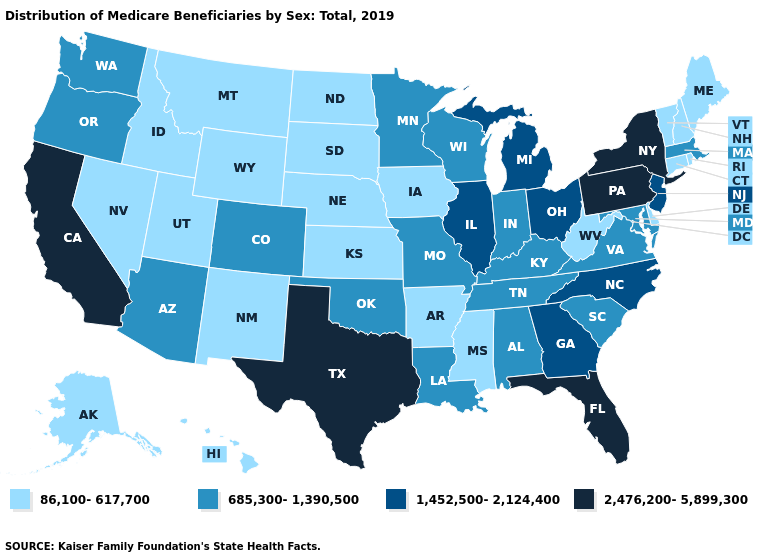Which states hav the highest value in the Northeast?
Keep it brief. New York, Pennsylvania. What is the value of Michigan?
Concise answer only. 1,452,500-2,124,400. What is the highest value in the USA?
Be succinct. 2,476,200-5,899,300. Does Hawaii have the lowest value in the USA?
Concise answer only. Yes. Among the states that border Louisiana , does Arkansas have the highest value?
Keep it brief. No. Name the states that have a value in the range 1,452,500-2,124,400?
Answer briefly. Georgia, Illinois, Michigan, New Jersey, North Carolina, Ohio. Does New York have the highest value in the USA?
Short answer required. Yes. Name the states that have a value in the range 2,476,200-5,899,300?
Quick response, please. California, Florida, New York, Pennsylvania, Texas. Does the map have missing data?
Write a very short answer. No. What is the value of Rhode Island?
Give a very brief answer. 86,100-617,700. Which states have the lowest value in the MidWest?
Short answer required. Iowa, Kansas, Nebraska, North Dakota, South Dakota. Does Tennessee have a higher value than Massachusetts?
Short answer required. No. Name the states that have a value in the range 2,476,200-5,899,300?
Be succinct. California, Florida, New York, Pennsylvania, Texas. What is the highest value in the West ?
Answer briefly. 2,476,200-5,899,300. What is the highest value in the USA?
Concise answer only. 2,476,200-5,899,300. 